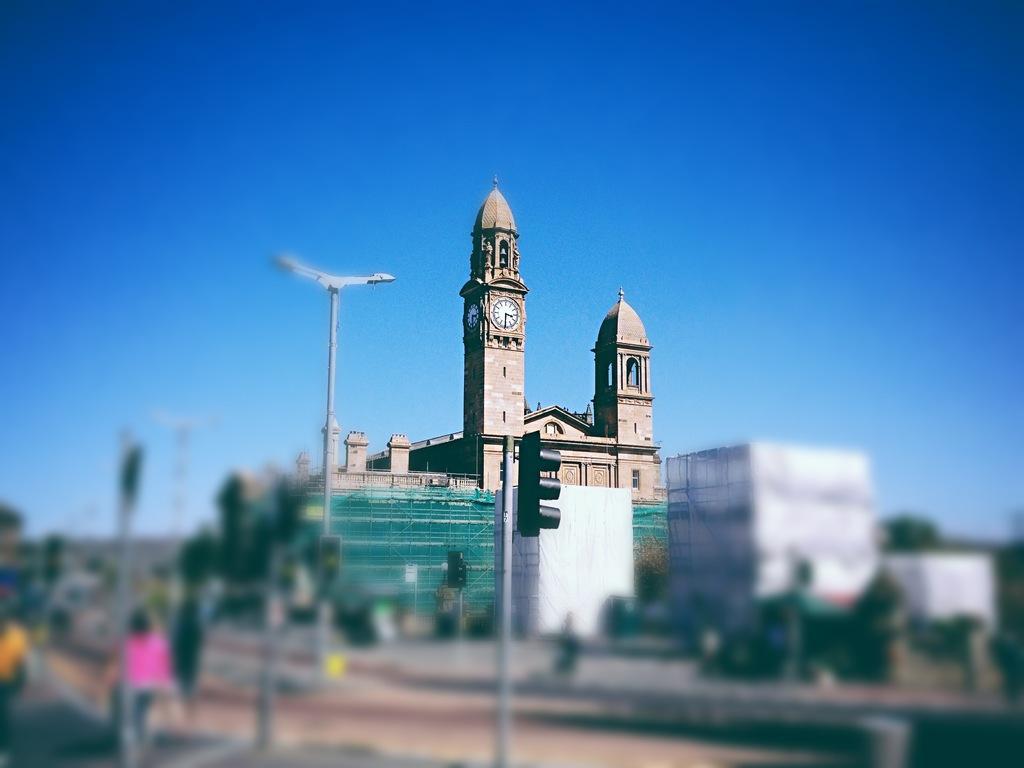Could you give a brief overview of what you see in this image? In the middle it is a clock tower, at the bottom there is a signal. At the top it is the sky in this image. 